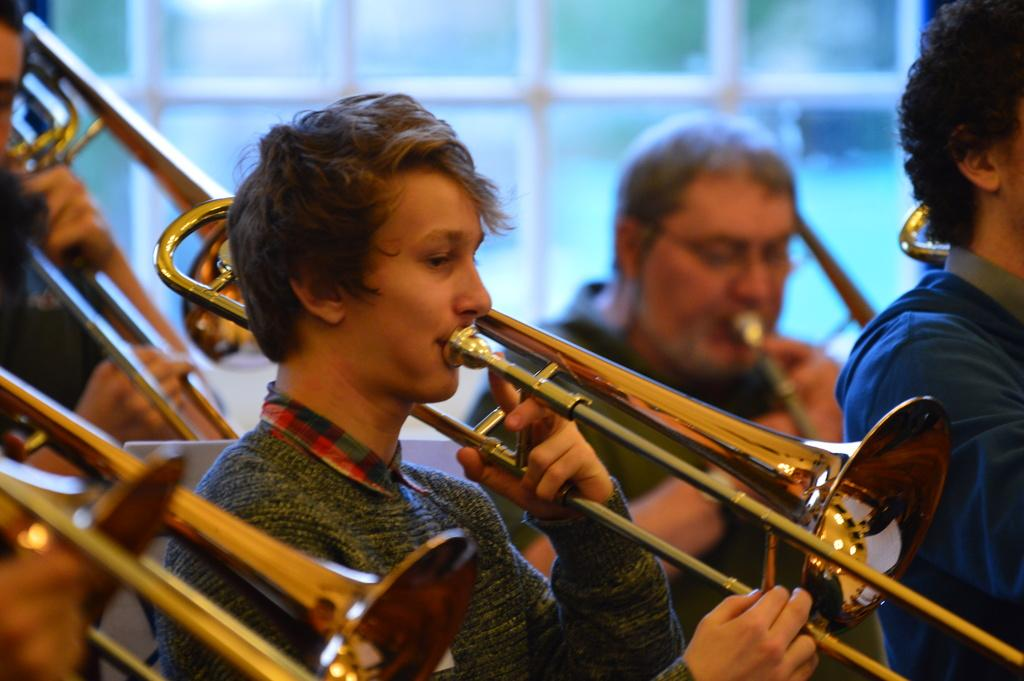What is happening in the image? There are people in the image, and they are playing a saxophone. Can you describe the background of the image? The background of the image is blurred. How many hens can be seen in the image? There are no hens present in the image. What type of rock is visible in the image? There is no rock visible in the image. 